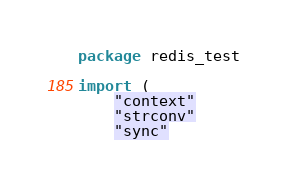Convert code to text. <code><loc_0><loc_0><loc_500><loc_500><_Go_>package redis_test

import (
	"context"
	"strconv"
	"sync"
</code> 